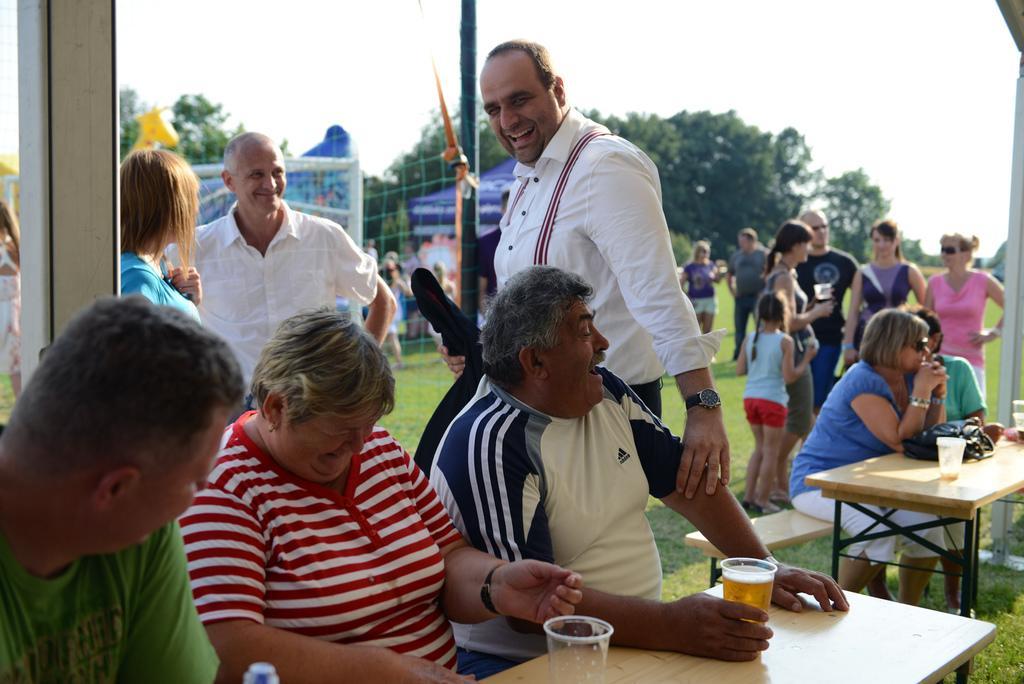How would you summarize this image in a sentence or two? Here we can see a few people and they are all smiling. This is a wooden table where glasses are kept it. In the background we can see a few people , a tree and a net. 